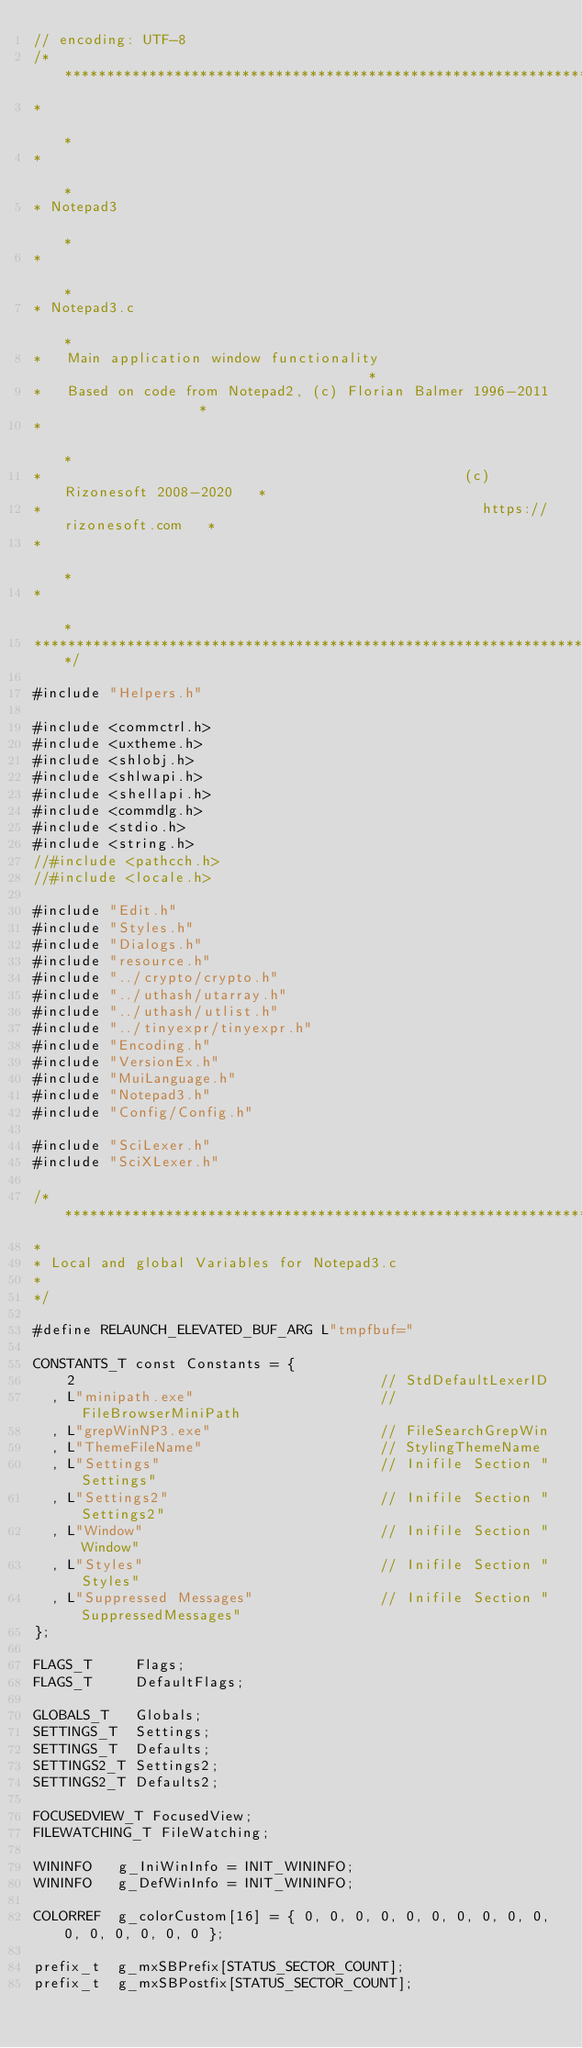Convert code to text. <code><loc_0><loc_0><loc_500><loc_500><_C_>// encoding: UTF-8
/******************************************************************************
*                                                                             *
*                                                                             *
* Notepad3                                                                    *
*                                                                             *
* Notepad3.c                                                                  *
*   Main application window functionality                                     *
*   Based on code from Notepad2, (c) Florian Balmer 1996-2011                 *
*                                                                             *
*                                                  (c) Rizonesoft 2008-2020   *
*                                                    https://rizonesoft.com   *
*                                                                             *
*                                                                             *
*******************************************************************************/

#include "Helpers.h"

#include <commctrl.h>
#include <uxtheme.h>
#include <shlobj.h>
#include <shlwapi.h>
#include <shellapi.h>
#include <commdlg.h>
#include <stdio.h>
#include <string.h>
//#include <pathcch.h>
//#include <locale.h>

#include "Edit.h"
#include "Styles.h"
#include "Dialogs.h"
#include "resource.h"
#include "../crypto/crypto.h"
#include "../uthash/utarray.h"
#include "../uthash/utlist.h"
#include "../tinyexpr/tinyexpr.h"
#include "Encoding.h"
#include "VersionEx.h"
#include "MuiLanguage.h"
#include "Notepad3.h"
#include "Config/Config.h"

#include "SciLexer.h"
#include "SciXLexer.h"

/******************************************************************************
*
* Local and global Variables for Notepad3.c
*
*/

#define RELAUNCH_ELEVATED_BUF_ARG L"tmpfbuf="

CONSTANTS_T const Constants = { 
    2                                    // StdDefaultLexerID
  , L"minipath.exe"                      // FileBrowserMiniPath
  , L"grepWinNP3.exe"                    // FileSearchGrepWin
  , L"ThemeFileName"                     // StylingThemeName
  , L"Settings"                          // Inifile Section "Settings"
  , L"Settings2"                         // Inifile Section "Settings2"
  , L"Window"                            // Inifile Section "Window"
  , L"Styles"                            // Inifile Section "Styles"
  , L"Suppressed Messages"               // Inifile Section "SuppressedMessages"
};

FLAGS_T     Flags;
FLAGS_T     DefaultFlags;

GLOBALS_T   Globals;
SETTINGS_T  Settings;
SETTINGS_T  Defaults;
SETTINGS2_T Settings2;
SETTINGS2_T Defaults2;

FOCUSEDVIEW_T FocusedView;
FILEWATCHING_T FileWatching;

WININFO   g_IniWinInfo = INIT_WININFO;
WININFO   g_DefWinInfo = INIT_WININFO;

COLORREF  g_colorCustom[16] = { 0, 0, 0, 0, 0, 0, 0, 0, 0, 0, 0, 0, 0, 0, 0, 0 };

prefix_t  g_mxSBPrefix[STATUS_SECTOR_COUNT];
prefix_t  g_mxSBPostfix[STATUS_SECTOR_COUNT];
</code> 